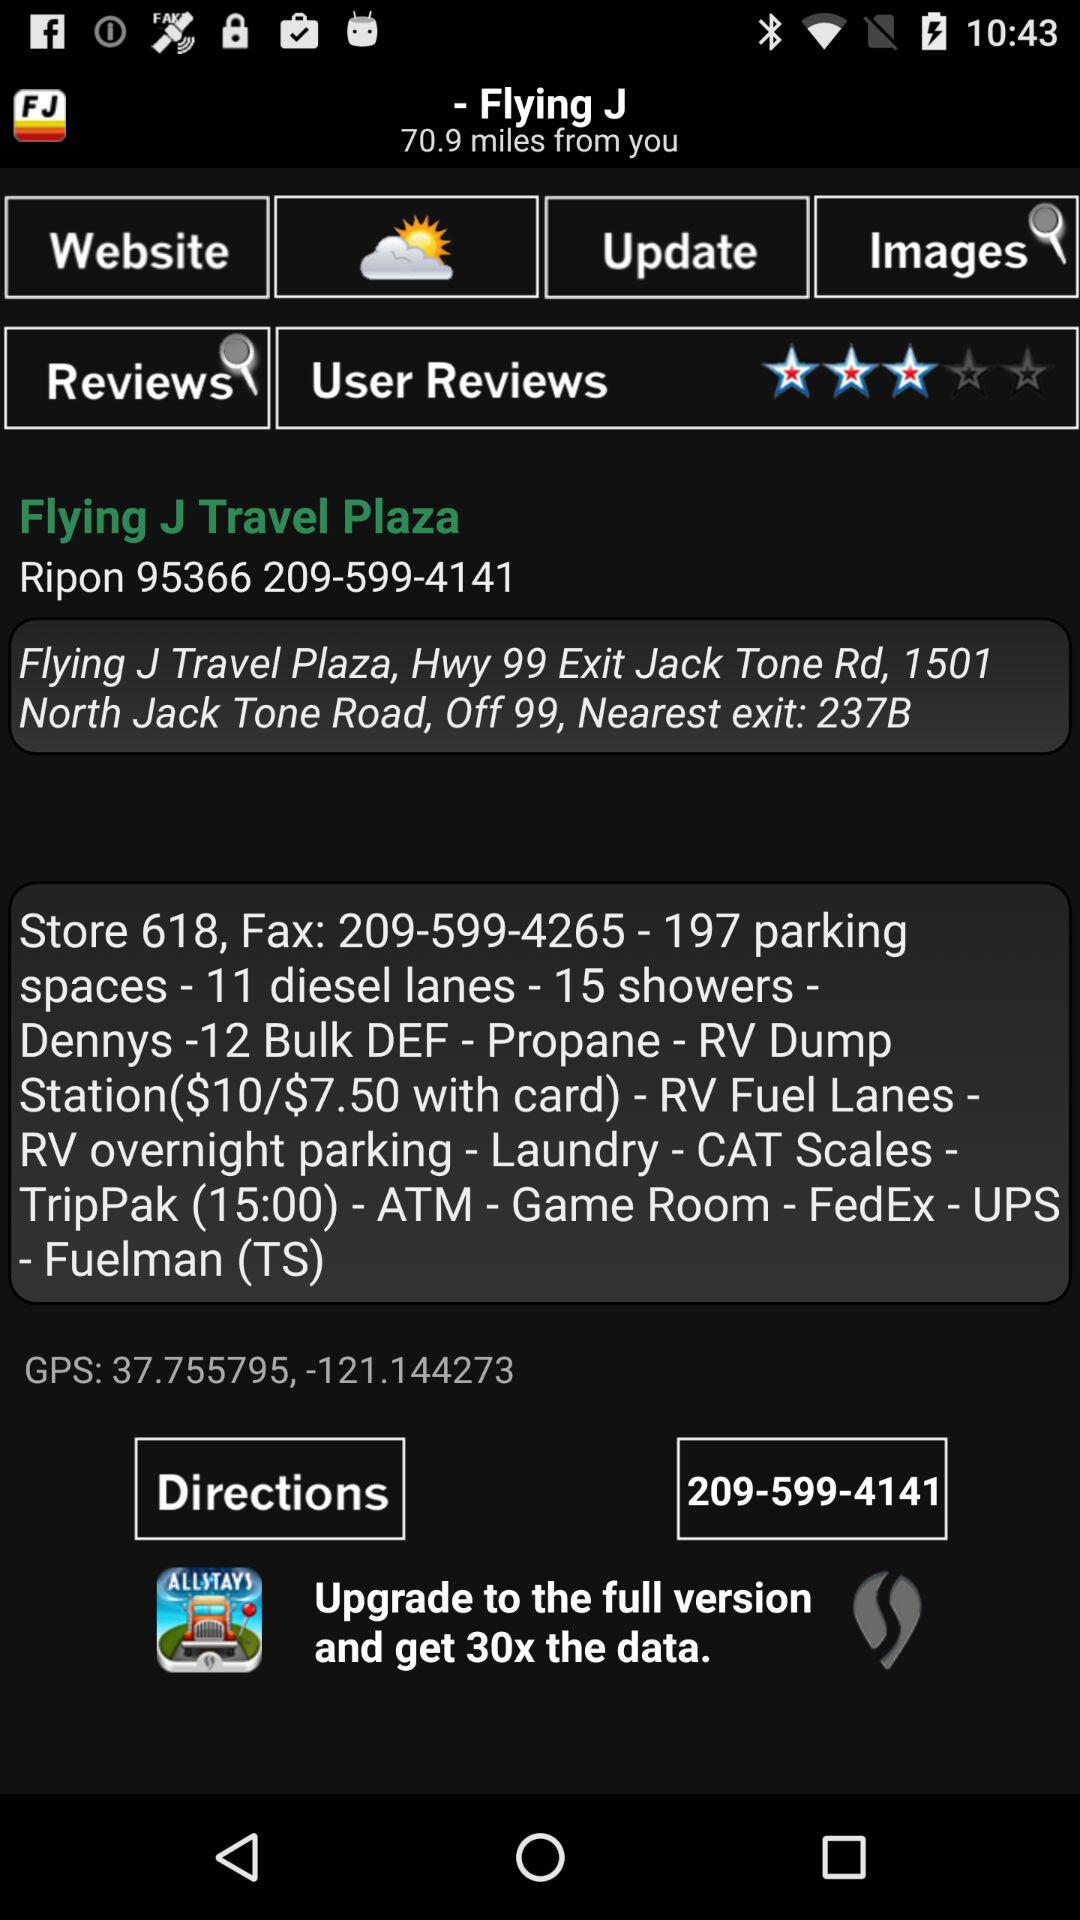What is the GPS latitude? The GPS latitude is 37.755795. 